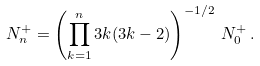Convert formula to latex. <formula><loc_0><loc_0><loc_500><loc_500>N _ { n } ^ { + } = \left ( \prod _ { k = 1 } ^ { n } 3 k ( 3 k - 2 ) \right ) ^ { - 1 / 2 } \, N _ { 0 } ^ { + } \, .</formula> 